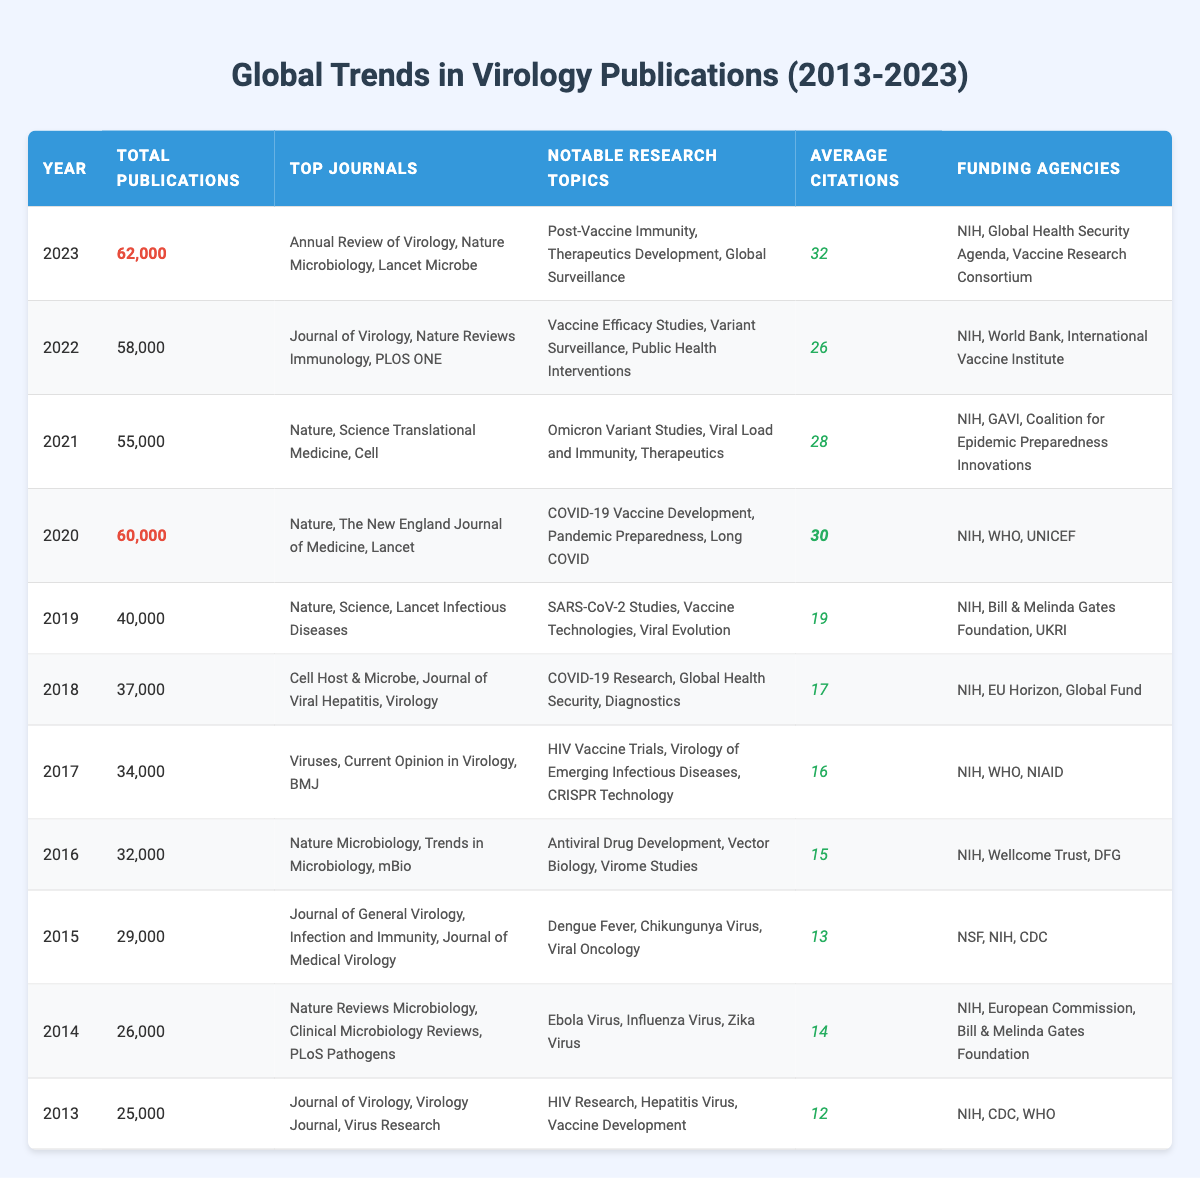What was the total number of virology publications in 2020? The table lists the total publications for each year, and for 2020, the total is directly indicated as 60,000.
Answer: 60,000 Which year had the highest average citations? The average citations for each year can be compared; the highest value is found in 2023, where the average citations are 32.
Answer: 32 What are the notable research topics for the year with the least total publications? The year with the least total publications is 2013 at 25,000; its notable research topics are listed as HIV Research, Hepatitis Virus, and Vaccine Development.
Answer: HIV Research, Hepatitis Virus, Vaccine Development How many more publications were there in 2022 compared to 2014? 2022 had 58,000 publications and 2014 had 26,000 publications; the difference is 58,000 - 26,000 = 32,000.
Answer: 32,000 Was the funding agency Bill & Melinda Gates Foundation involved in virology research funding in 2016? By checking 2016's funding agencies in the table, it is clear that the Bill & Melinda Gates Foundation is not listed, so the answer is no.
Answer: No What was the change in total publications from 2019 to 2021? Total publications in 2019 were 40,000 and in 2021 they were 55,000. The change is 55,000 - 40,000 = 15,000, indicating an increase in publications.
Answer: 15,000 increase What is the average number of publications for the years 2020, 2021, and 2022 combined? The total publications for these years are 60,000 (2020), 55,000 (2021), and 58,000 (2022). Sum them to get 60,000 + 55,000 + 58,000 = 173,000. There are 3 years, so the average is 173,000 / 3 = 57,666.67.
Answer: 57,666.67 Identify the top journals for the year with the most publications. In 2020, which had the highest total publications at 60,000, the top journals listed are Nature, The New England Journal of Medicine, and Lancet.
Answer: Nature, The New England Journal of Medicine, Lancet Was there a decline in total publications from 2021 to 2022? In 2021, the total publications were 55,000, and in 2022, it was 58,000; since the number increased, the answer is no.
Answer: No What is the year-on-year publication growth rate between 2020 and 2021? From 2020 to 2021, total publications changed from 60,000 to 55,000, indicating a growth rate of (55,000 - 60,000) / 60,000 * 100 = -8.33%, meaning a decline.
Answer: -8.33% In which year was the highest number of virology-related research topics listed? The year 2023 mentioned three notable research topics: Post-Vaccine Immunity, Therapeutics Development, and Global Surveillance, which is the same as earlier years like 2020 and 2018 with three topics, making 2023 tied for most.
Answer: 2023 